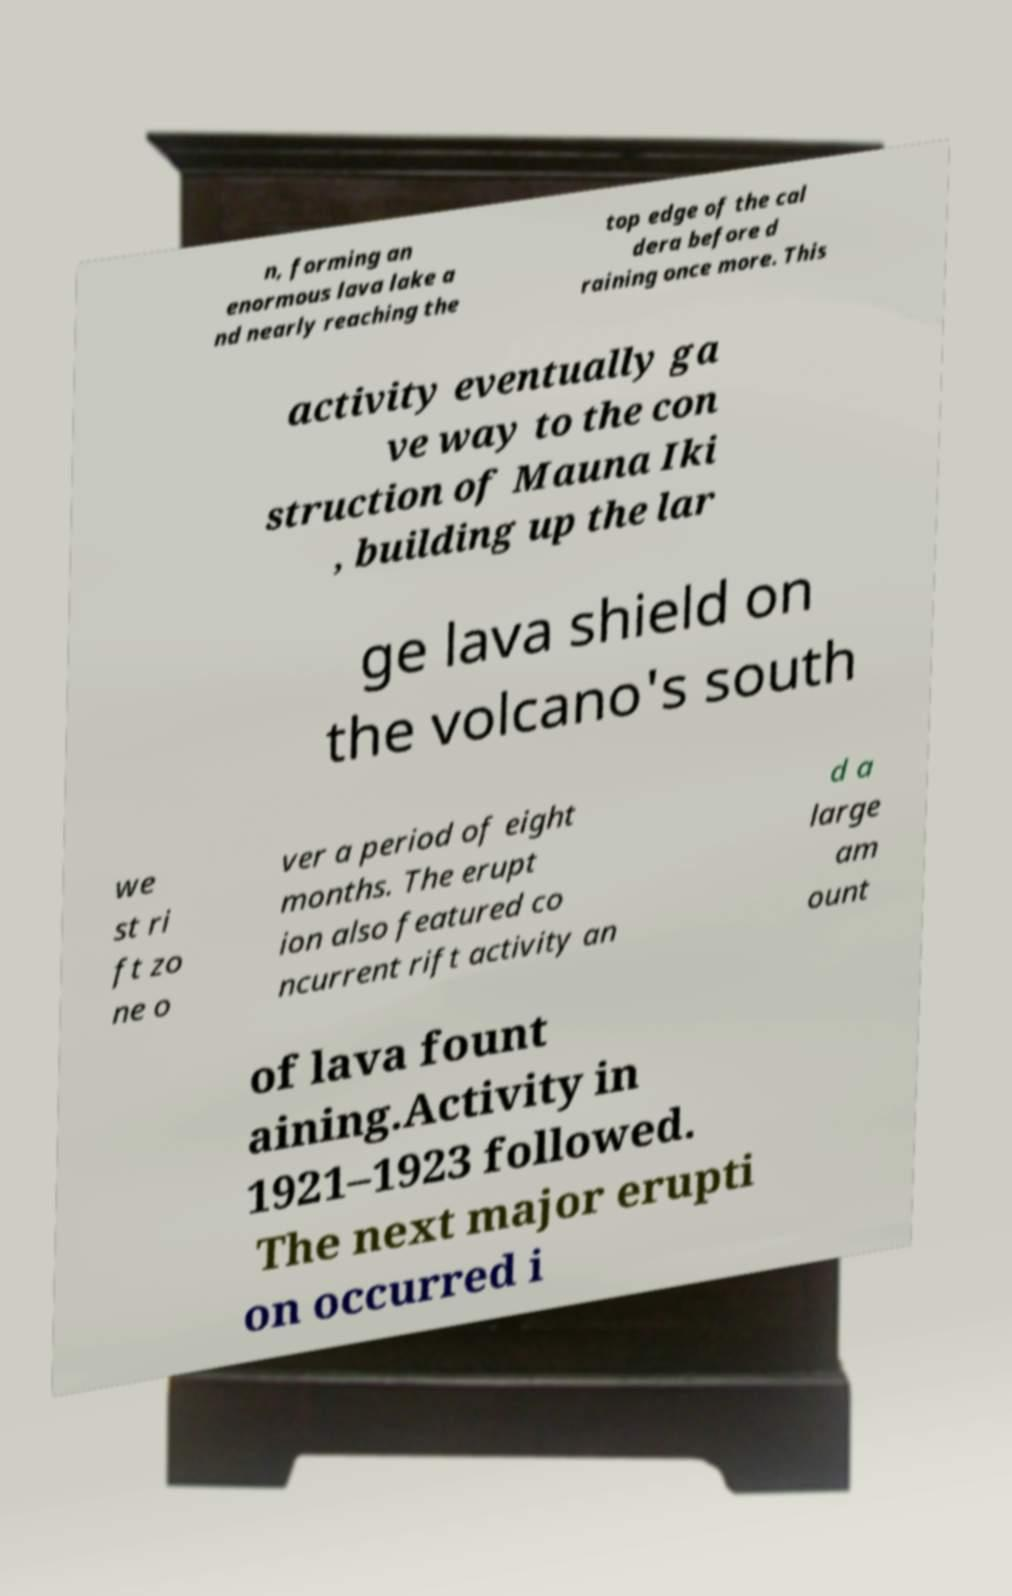What messages or text are displayed in this image? I need them in a readable, typed format. n, forming an enormous lava lake a nd nearly reaching the top edge of the cal dera before d raining once more. This activity eventually ga ve way to the con struction of Mauna Iki , building up the lar ge lava shield on the volcano's south we st ri ft zo ne o ver a period of eight months. The erupt ion also featured co ncurrent rift activity an d a large am ount of lava fount aining.Activity in 1921–1923 followed. The next major erupti on occurred i 